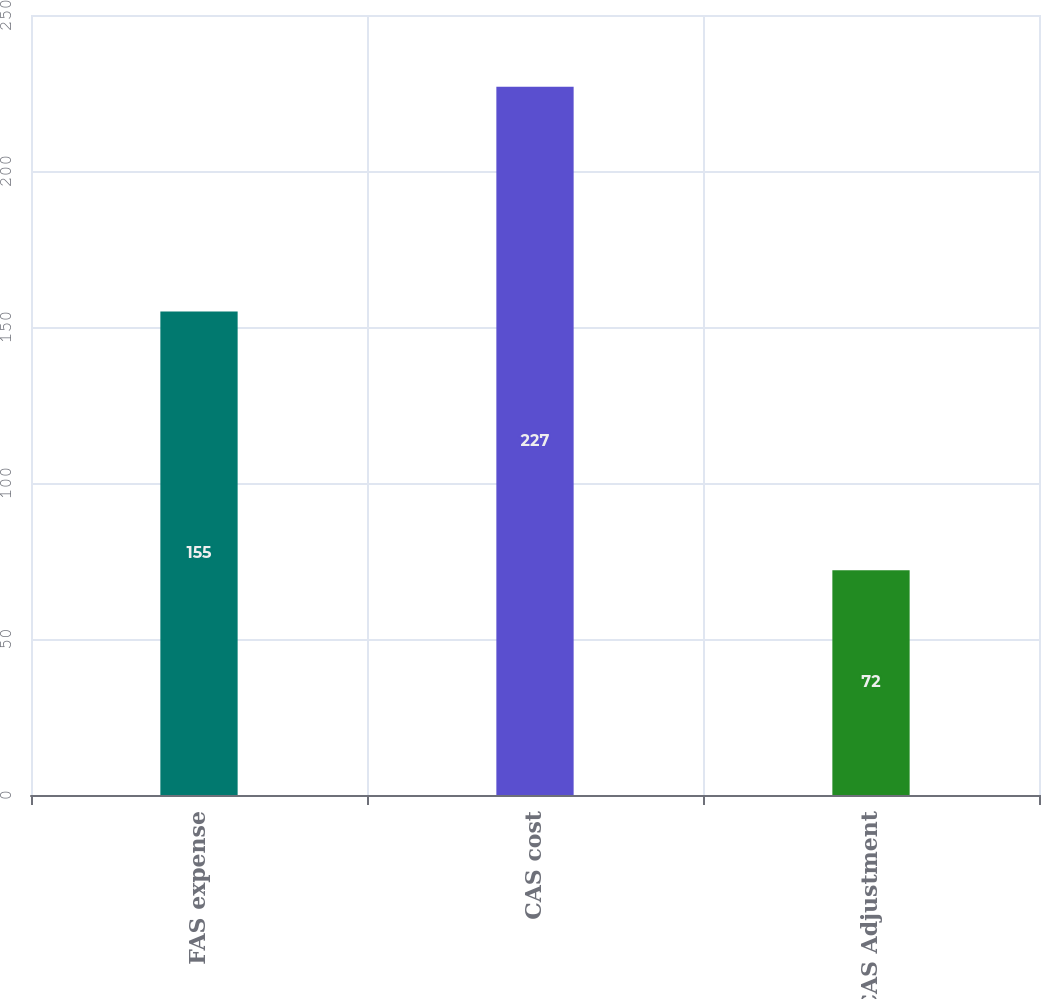Convert chart. <chart><loc_0><loc_0><loc_500><loc_500><bar_chart><fcel>FAS expense<fcel>CAS cost<fcel>FAS/CAS Adjustment<nl><fcel>155<fcel>227<fcel>72<nl></chart> 